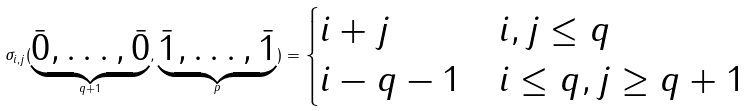Convert formula to latex. <formula><loc_0><loc_0><loc_500><loc_500>\sigma _ { i , j } ( \underbrace { \bar { 0 } , \dots , \bar { 0 } } _ { q + 1 } , \underbrace { \bar { 1 } , \dots , \bar { 1 } } _ { p } ) = \begin{cases} i + j & i , j \leq q \\ i - q - 1 & i \leq q , j \geq q + 1 \end{cases}</formula> 